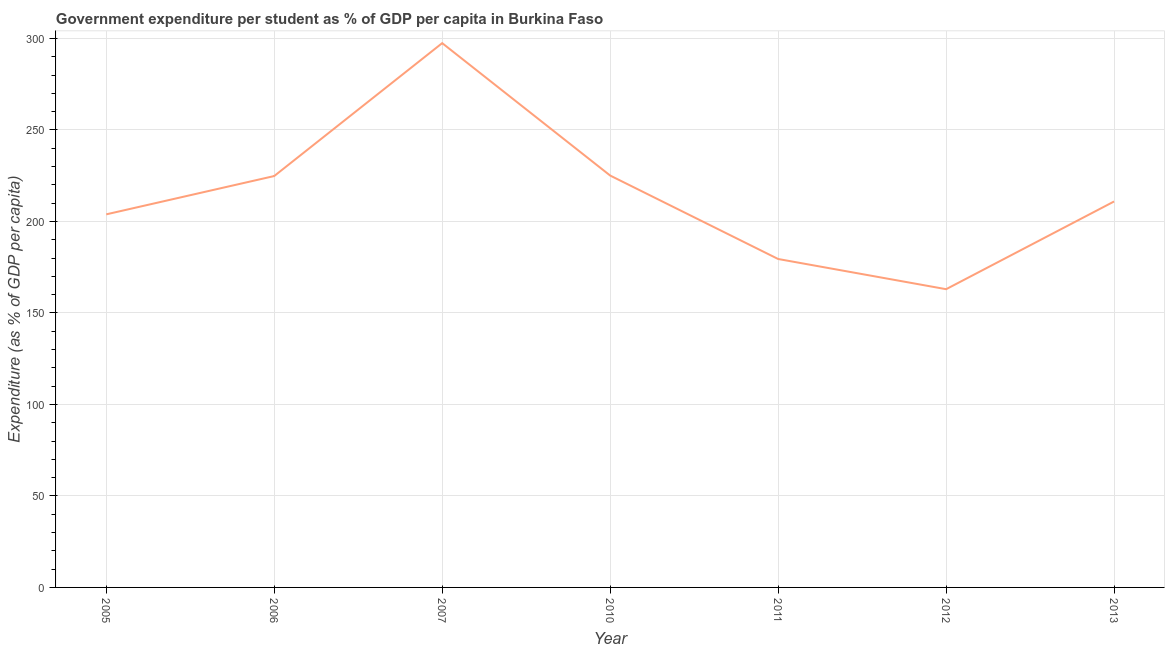What is the government expenditure per student in 2007?
Make the answer very short. 297.45. Across all years, what is the maximum government expenditure per student?
Make the answer very short. 297.45. Across all years, what is the minimum government expenditure per student?
Offer a terse response. 162.98. What is the sum of the government expenditure per student?
Give a very brief answer. 1504.62. What is the difference between the government expenditure per student in 2012 and 2013?
Your response must be concise. -47.94. What is the average government expenditure per student per year?
Provide a short and direct response. 214.95. What is the median government expenditure per student?
Provide a short and direct response. 210.92. In how many years, is the government expenditure per student greater than 40 %?
Offer a very short reply. 7. What is the ratio of the government expenditure per student in 2010 to that in 2012?
Your answer should be very brief. 1.38. What is the difference between the highest and the second highest government expenditure per student?
Your answer should be very brief. 72.37. Is the sum of the government expenditure per student in 2005 and 2010 greater than the maximum government expenditure per student across all years?
Offer a terse response. Yes. What is the difference between the highest and the lowest government expenditure per student?
Offer a very short reply. 134.47. In how many years, is the government expenditure per student greater than the average government expenditure per student taken over all years?
Make the answer very short. 3. Does the government expenditure per student monotonically increase over the years?
Make the answer very short. No. Does the graph contain grids?
Make the answer very short. Yes. What is the title of the graph?
Provide a succinct answer. Government expenditure per student as % of GDP per capita in Burkina Faso. What is the label or title of the X-axis?
Offer a terse response. Year. What is the label or title of the Y-axis?
Offer a very short reply. Expenditure (as % of GDP per capita). What is the Expenditure (as % of GDP per capita) of 2005?
Your answer should be very brief. 203.88. What is the Expenditure (as % of GDP per capita) in 2006?
Offer a very short reply. 224.82. What is the Expenditure (as % of GDP per capita) in 2007?
Ensure brevity in your answer.  297.45. What is the Expenditure (as % of GDP per capita) in 2010?
Provide a succinct answer. 225.08. What is the Expenditure (as % of GDP per capita) in 2011?
Offer a very short reply. 179.48. What is the Expenditure (as % of GDP per capita) of 2012?
Keep it short and to the point. 162.98. What is the Expenditure (as % of GDP per capita) in 2013?
Your response must be concise. 210.92. What is the difference between the Expenditure (as % of GDP per capita) in 2005 and 2006?
Make the answer very short. -20.94. What is the difference between the Expenditure (as % of GDP per capita) in 2005 and 2007?
Your answer should be very brief. -93.57. What is the difference between the Expenditure (as % of GDP per capita) in 2005 and 2010?
Offer a terse response. -21.21. What is the difference between the Expenditure (as % of GDP per capita) in 2005 and 2011?
Give a very brief answer. 24.4. What is the difference between the Expenditure (as % of GDP per capita) in 2005 and 2012?
Your answer should be compact. 40.89. What is the difference between the Expenditure (as % of GDP per capita) in 2005 and 2013?
Ensure brevity in your answer.  -7.04. What is the difference between the Expenditure (as % of GDP per capita) in 2006 and 2007?
Keep it short and to the point. -72.63. What is the difference between the Expenditure (as % of GDP per capita) in 2006 and 2010?
Ensure brevity in your answer.  -0.26. What is the difference between the Expenditure (as % of GDP per capita) in 2006 and 2011?
Offer a very short reply. 45.34. What is the difference between the Expenditure (as % of GDP per capita) in 2006 and 2012?
Keep it short and to the point. 61.84. What is the difference between the Expenditure (as % of GDP per capita) in 2006 and 2013?
Provide a succinct answer. 13.9. What is the difference between the Expenditure (as % of GDP per capita) in 2007 and 2010?
Provide a short and direct response. 72.37. What is the difference between the Expenditure (as % of GDP per capita) in 2007 and 2011?
Provide a short and direct response. 117.97. What is the difference between the Expenditure (as % of GDP per capita) in 2007 and 2012?
Your response must be concise. 134.47. What is the difference between the Expenditure (as % of GDP per capita) in 2007 and 2013?
Offer a very short reply. 86.53. What is the difference between the Expenditure (as % of GDP per capita) in 2010 and 2011?
Offer a very short reply. 45.6. What is the difference between the Expenditure (as % of GDP per capita) in 2010 and 2012?
Give a very brief answer. 62.1. What is the difference between the Expenditure (as % of GDP per capita) in 2010 and 2013?
Offer a terse response. 14.16. What is the difference between the Expenditure (as % of GDP per capita) in 2011 and 2012?
Your answer should be compact. 16.5. What is the difference between the Expenditure (as % of GDP per capita) in 2011 and 2013?
Make the answer very short. -31.44. What is the difference between the Expenditure (as % of GDP per capita) in 2012 and 2013?
Your response must be concise. -47.94. What is the ratio of the Expenditure (as % of GDP per capita) in 2005 to that in 2006?
Your response must be concise. 0.91. What is the ratio of the Expenditure (as % of GDP per capita) in 2005 to that in 2007?
Give a very brief answer. 0.69. What is the ratio of the Expenditure (as % of GDP per capita) in 2005 to that in 2010?
Provide a succinct answer. 0.91. What is the ratio of the Expenditure (as % of GDP per capita) in 2005 to that in 2011?
Offer a very short reply. 1.14. What is the ratio of the Expenditure (as % of GDP per capita) in 2005 to that in 2012?
Provide a short and direct response. 1.25. What is the ratio of the Expenditure (as % of GDP per capita) in 2005 to that in 2013?
Keep it short and to the point. 0.97. What is the ratio of the Expenditure (as % of GDP per capita) in 2006 to that in 2007?
Offer a very short reply. 0.76. What is the ratio of the Expenditure (as % of GDP per capita) in 2006 to that in 2010?
Make the answer very short. 1. What is the ratio of the Expenditure (as % of GDP per capita) in 2006 to that in 2011?
Keep it short and to the point. 1.25. What is the ratio of the Expenditure (as % of GDP per capita) in 2006 to that in 2012?
Provide a short and direct response. 1.38. What is the ratio of the Expenditure (as % of GDP per capita) in 2006 to that in 2013?
Offer a terse response. 1.07. What is the ratio of the Expenditure (as % of GDP per capita) in 2007 to that in 2010?
Your answer should be very brief. 1.32. What is the ratio of the Expenditure (as % of GDP per capita) in 2007 to that in 2011?
Offer a terse response. 1.66. What is the ratio of the Expenditure (as % of GDP per capita) in 2007 to that in 2012?
Your answer should be very brief. 1.82. What is the ratio of the Expenditure (as % of GDP per capita) in 2007 to that in 2013?
Make the answer very short. 1.41. What is the ratio of the Expenditure (as % of GDP per capita) in 2010 to that in 2011?
Keep it short and to the point. 1.25. What is the ratio of the Expenditure (as % of GDP per capita) in 2010 to that in 2012?
Provide a short and direct response. 1.38. What is the ratio of the Expenditure (as % of GDP per capita) in 2010 to that in 2013?
Your answer should be very brief. 1.07. What is the ratio of the Expenditure (as % of GDP per capita) in 2011 to that in 2012?
Your answer should be compact. 1.1. What is the ratio of the Expenditure (as % of GDP per capita) in 2011 to that in 2013?
Provide a short and direct response. 0.85. What is the ratio of the Expenditure (as % of GDP per capita) in 2012 to that in 2013?
Offer a terse response. 0.77. 